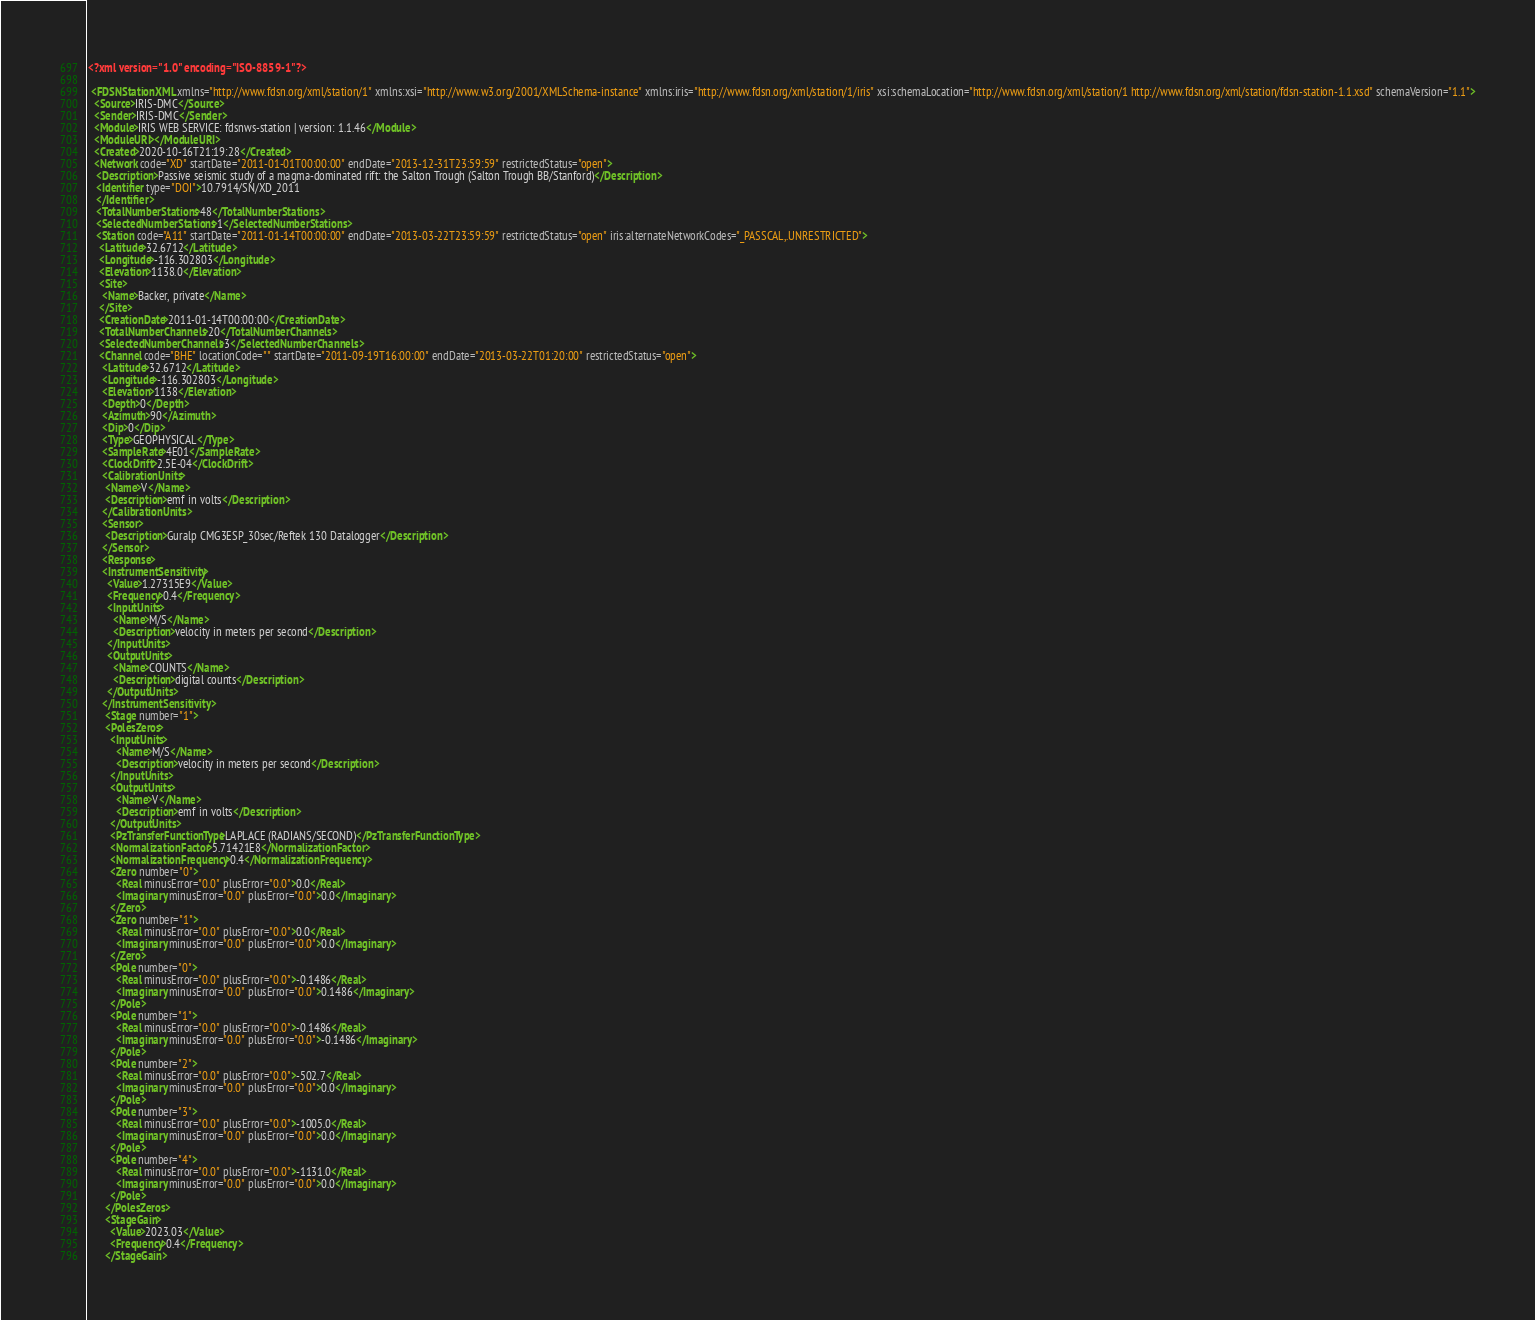Convert code to text. <code><loc_0><loc_0><loc_500><loc_500><_XML_><?xml version="1.0" encoding="ISO-8859-1"?>

 <FDSNStationXML xmlns="http://www.fdsn.org/xml/station/1" xmlns:xsi="http://www.w3.org/2001/XMLSchema-instance" xmlns:iris="http://www.fdsn.org/xml/station/1/iris" xsi:schemaLocation="http://www.fdsn.org/xml/station/1 http://www.fdsn.org/xml/station/fdsn-station-1.1.xsd" schemaVersion="1.1">
  <Source>IRIS-DMC</Source>
  <Sender>IRIS-DMC</Sender>
  <Module>IRIS WEB SERVICE: fdsnws-station | version: 1.1.46</Module>
  <ModuleURI></ModuleURI>
  <Created>2020-10-16T21:19:28</Created>
  <Network code="XD" startDate="2011-01-01T00:00:00" endDate="2013-12-31T23:59:59" restrictedStatus="open">
   <Description>Passive seismic study of a magma-dominated rift: the Salton Trough (Salton Trough BB/Stanford)</Description>
   <Identifier type="DOI">10.7914/SN/XD_2011
   </Identifier>
   <TotalNumberStations>48</TotalNumberStations>
   <SelectedNumberStations>1</SelectedNumberStations>
   <Station code="A11" startDate="2011-01-14T00:00:00" endDate="2013-03-22T23:59:59" restrictedStatus="open" iris:alternateNetworkCodes="_PASSCAL,.UNRESTRICTED">
    <Latitude>32.6712</Latitude>
    <Longitude>-116.302803</Longitude>
    <Elevation>1138.0</Elevation>
    <Site>
     <Name>Backer, private</Name>
    </Site>
    <CreationDate>2011-01-14T00:00:00</CreationDate>
    <TotalNumberChannels>20</TotalNumberChannels>
    <SelectedNumberChannels>3</SelectedNumberChannels>
    <Channel code="BHE" locationCode="" startDate="2011-09-19T16:00:00" endDate="2013-03-22T01:20:00" restrictedStatus="open">
     <Latitude>32.6712</Latitude>
     <Longitude>-116.302803</Longitude>
     <Elevation>1138</Elevation>
     <Depth>0</Depth>
     <Azimuth>90</Azimuth>
     <Dip>0</Dip>
     <Type>GEOPHYSICAL</Type>
     <SampleRate>4E01</SampleRate>
     <ClockDrift>2.5E-04</ClockDrift>
     <CalibrationUnits>
      <Name>V</Name>
      <Description>emf in volts</Description>
     </CalibrationUnits>
     <Sensor>
      <Description>Guralp CMG3ESP_30sec/Reftek 130 Datalogger</Description>
     </Sensor>
     <Response>
     <InstrumentSensitivity>
       <Value>1.27315E9</Value>
       <Frequency>0.4</Frequency>
       <InputUnits>
         <Name>M/S</Name>
         <Description>velocity in meters per second</Description>
       </InputUnits>
       <OutputUnits>
         <Name>COUNTS</Name>
         <Description>digital counts</Description>
       </OutputUnits>
     </InstrumentSensitivity>
      <Stage number="1">
      <PolesZeros>
        <InputUnits>
          <Name>M/S</Name>
          <Description>velocity in meters per second</Description>
        </InputUnits>
        <OutputUnits>
          <Name>V</Name>
          <Description>emf in volts</Description>
        </OutputUnits>
        <PzTransferFunctionType>LAPLACE (RADIANS/SECOND)</PzTransferFunctionType>
        <NormalizationFactor>5.71421E8</NormalizationFactor>
        <NormalizationFrequency>0.4</NormalizationFrequency>
        <Zero number="0">
          <Real minusError="0.0" plusError="0.0">0.0</Real>
          <Imaginary minusError="0.0" plusError="0.0">0.0</Imaginary>
        </Zero>
        <Zero number="1">
          <Real minusError="0.0" plusError="0.0">0.0</Real>
          <Imaginary minusError="0.0" plusError="0.0">0.0</Imaginary>
        </Zero>
        <Pole number="0">
          <Real minusError="0.0" plusError="0.0">-0.1486</Real>
          <Imaginary minusError="0.0" plusError="0.0">0.1486</Imaginary>
        </Pole>
        <Pole number="1">
          <Real minusError="0.0" plusError="0.0">-0.1486</Real>
          <Imaginary minusError="0.0" plusError="0.0">-0.1486</Imaginary>
        </Pole>
        <Pole number="2">
          <Real minusError="0.0" plusError="0.0">-502.7</Real>
          <Imaginary minusError="0.0" plusError="0.0">0.0</Imaginary>
        </Pole>
        <Pole number="3">
          <Real minusError="0.0" plusError="0.0">-1005.0</Real>
          <Imaginary minusError="0.0" plusError="0.0">0.0</Imaginary>
        </Pole>
        <Pole number="4">
          <Real minusError="0.0" plusError="0.0">-1131.0</Real>
          <Imaginary minusError="0.0" plusError="0.0">0.0</Imaginary>
        </Pole>
      </PolesZeros>
      <StageGain>
        <Value>2023.03</Value>
        <Frequency>0.4</Frequency>
      </StageGain>
</code> 